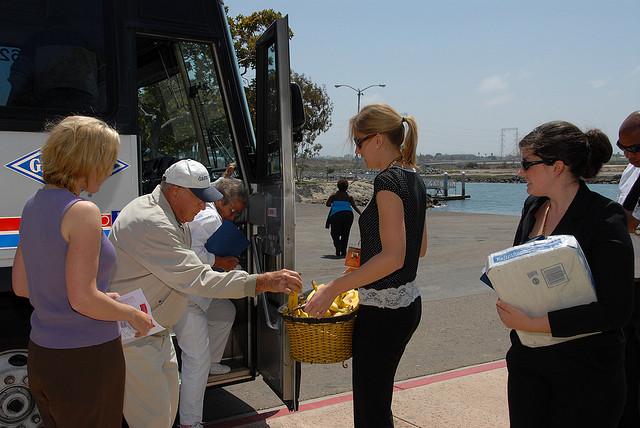Who is the man looking at?
Give a very brief answer. Bananas. Is this girl wearing a skirt?
Write a very short answer. No. What  is the old man carrying?
Short answer required. Banana. What are they doing?
Concise answer only. Selling fruit. Is a body of water near the people?
Answer briefly. Yes. Are they having fun?
Quick response, please. Yes. What is in the basket?
Concise answer only. Bananas. What color is the man's hat?
Concise answer only. White. How many pairs of sunglasses are there?
Be succinct. 2. Where are the sunglasses?
Be succinct. Face. What are the people looking at?
Short answer required. Fruit. What would be inside?
Give a very brief answer. People. 